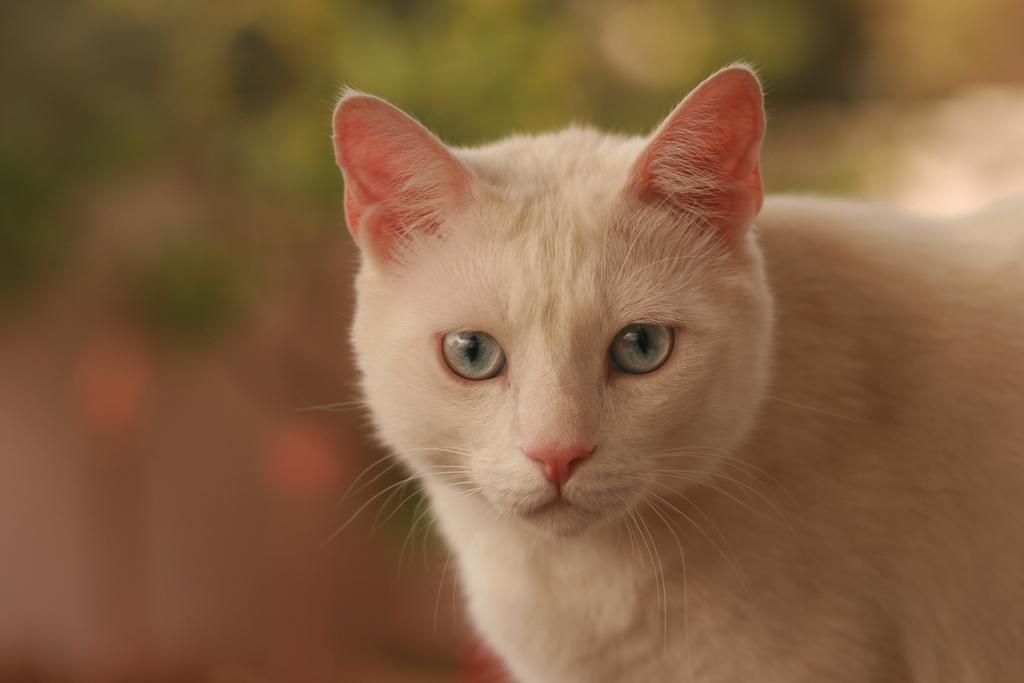Can you describe this image briefly? There is a white cat. The background is blurred. 